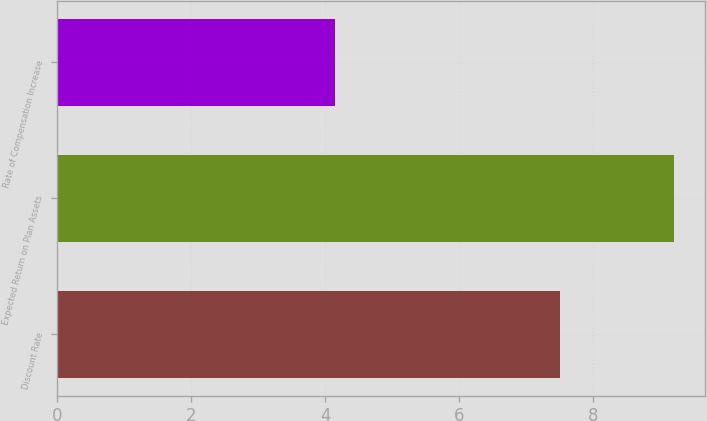<chart> <loc_0><loc_0><loc_500><loc_500><bar_chart><fcel>Discount Rate<fcel>Expected Return on Plan Assets<fcel>Rate of Compensation Increase<nl><fcel>7.5<fcel>9.2<fcel>4.15<nl></chart> 